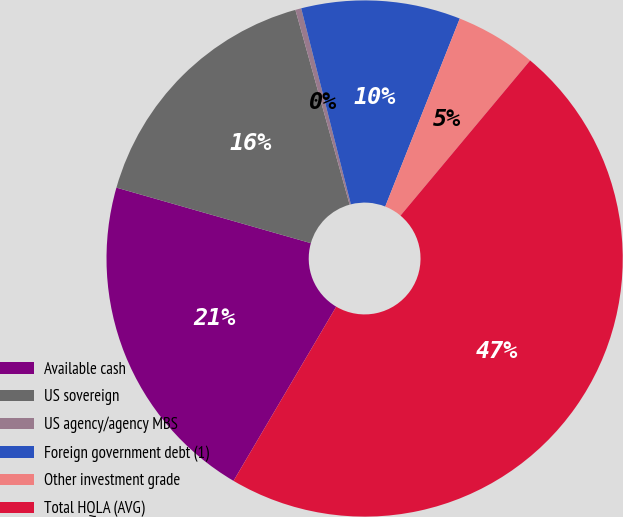Convert chart. <chart><loc_0><loc_0><loc_500><loc_500><pie_chart><fcel>Available cash<fcel>US sovereign<fcel>US agency/agency MBS<fcel>Foreign government debt (1)<fcel>Other investment grade<fcel>Total HQLA (AVG)<nl><fcel>20.95%<fcel>16.25%<fcel>0.37%<fcel>9.96%<fcel>5.07%<fcel>47.4%<nl></chart> 